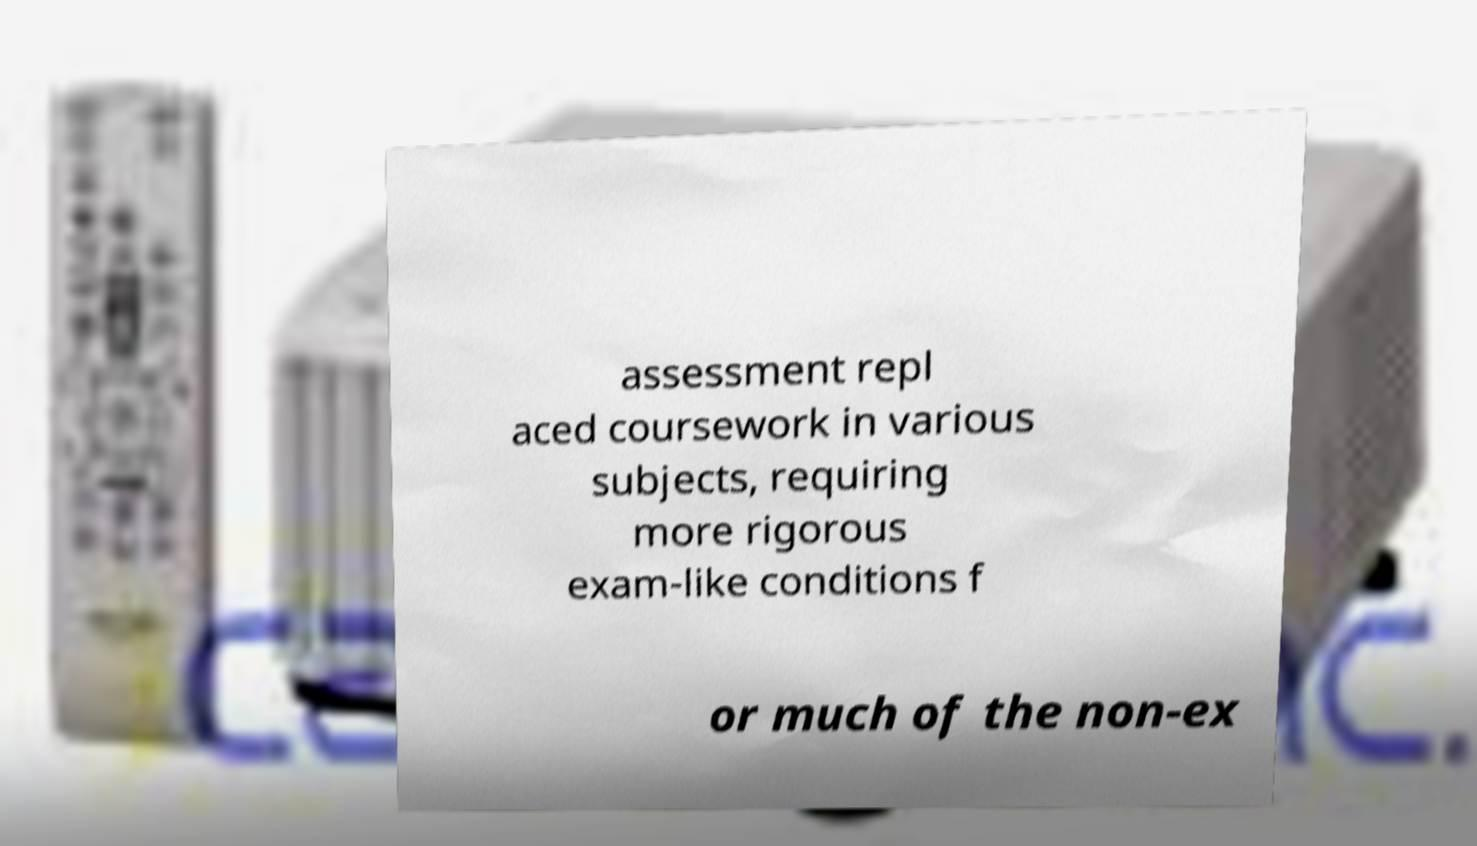Please identify and transcribe the text found in this image. assessment repl aced coursework in various subjects, requiring more rigorous exam-like conditions f or much of the non-ex 